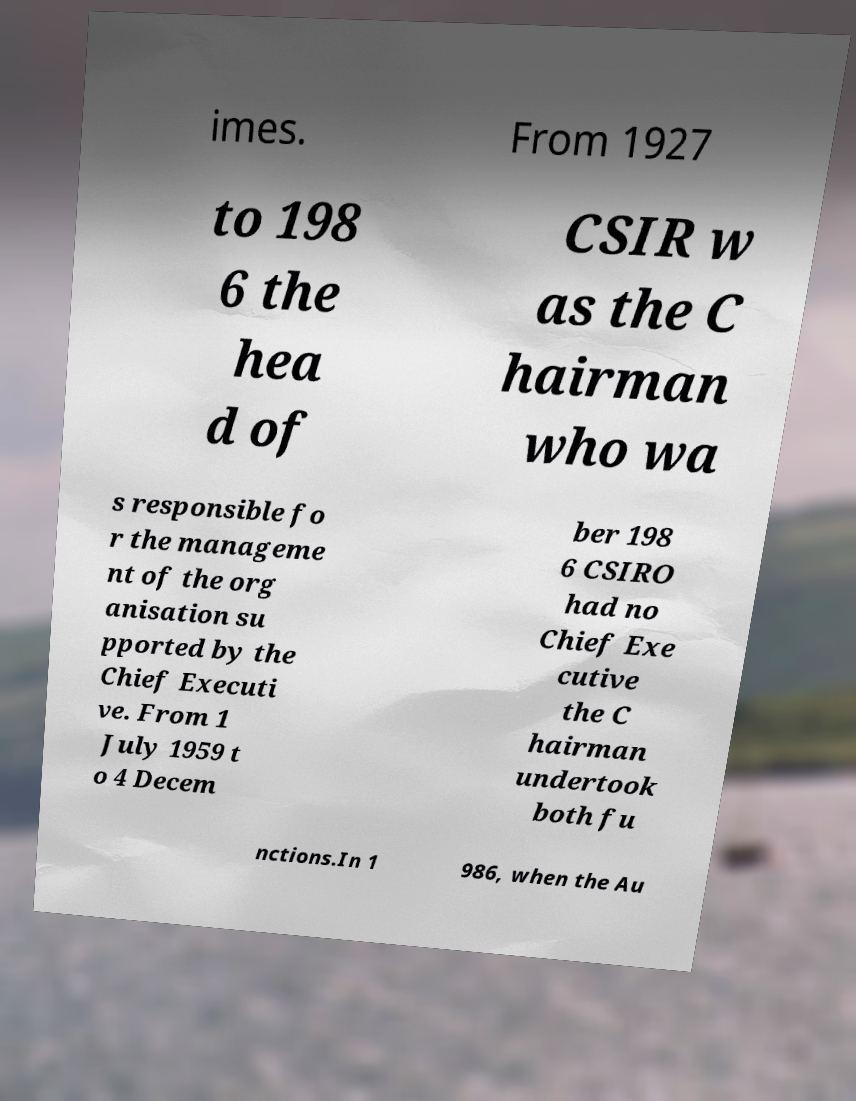Could you extract and type out the text from this image? imes. From 1927 to 198 6 the hea d of CSIR w as the C hairman who wa s responsible fo r the manageme nt of the org anisation su pported by the Chief Executi ve. From 1 July 1959 t o 4 Decem ber 198 6 CSIRO had no Chief Exe cutive the C hairman undertook both fu nctions.In 1 986, when the Au 